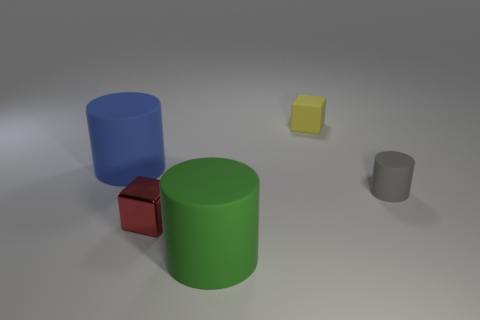Are there any other things that are made of the same material as the tiny red block?
Your answer should be very brief. No. The matte cylinder that is the same size as the red shiny object is what color?
Your answer should be compact. Gray. Are the large thing in front of the big blue cylinder and the red block made of the same material?
Provide a short and direct response. No. How big is the rubber cylinder that is both behind the metal thing and in front of the big blue rubber object?
Keep it short and to the point. Small. There is a object that is to the right of the small yellow rubber cube; what size is it?
Your response must be concise. Small. What shape is the small matte thing that is in front of the matte thing that is on the left side of the tiny metal block that is on the right side of the blue matte cylinder?
Your answer should be very brief. Cylinder. What number of other things are there of the same shape as the tiny gray matte object?
Provide a short and direct response. 2. What number of matte objects are either large red balls or green cylinders?
Your answer should be very brief. 1. The cube that is in front of the blue matte cylinder behind the red metal object is made of what material?
Offer a very short reply. Metal. Are there more tiny gray objects that are to the right of the yellow rubber object than yellow rubber spheres?
Your answer should be very brief. Yes. 